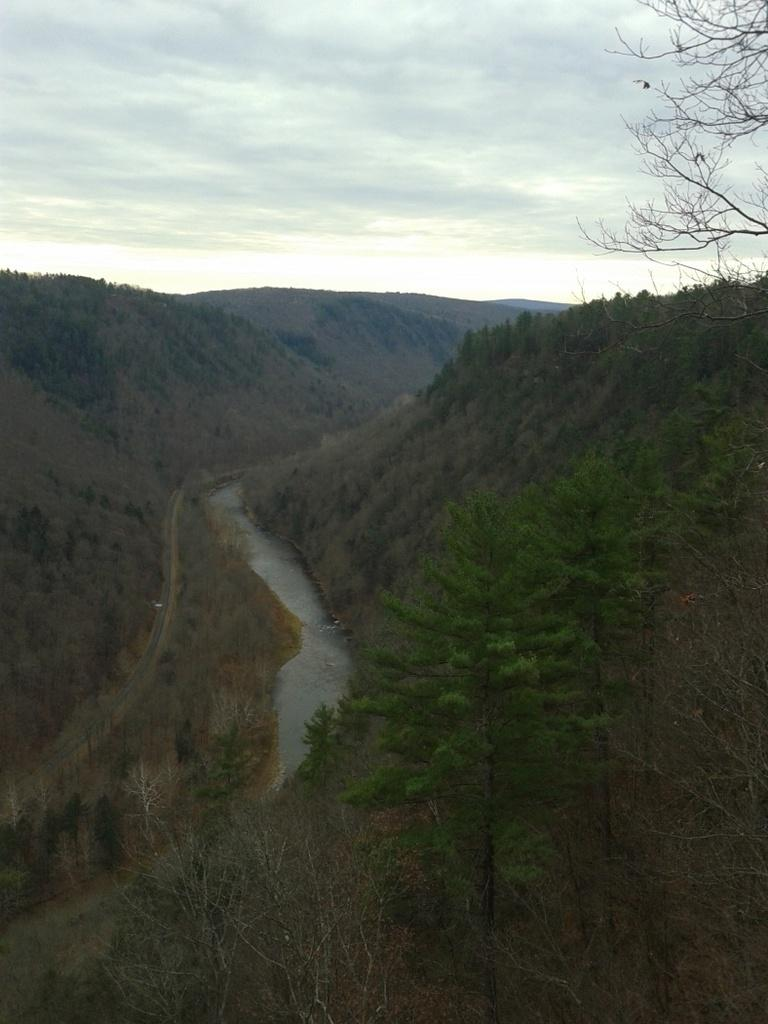What is the main feature of the image? The main feature of the image is a river flowing through hills. What type of landscape can be seen in the image? The landscape includes hills and trees. What is visible in the background of the image? The sky is visible in the image. How would you describe the weather in the image? The sky is cloudy, which suggests a potentially overcast or rainy day. What theory does the grandfather in the image propose about the river's origin? There is no mention of a grandfather or any theories in the image; it simply depicts a river flowing through hills. 